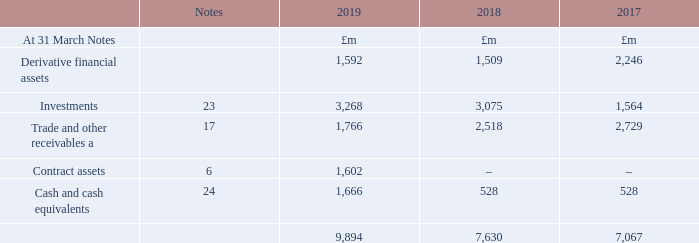Exposures The maximum credit risk exposure of the group’s financial assets at the balance sheet date is as follows:
The carrying amount excludes £445m (2017/18: £317m, 2016/17: £360m) of non-current trade and other receivables which relate to non-financial assets, and £1,456m (2017/18: £1,496m, 2016/17: £1,106m) of prepayments, deferred contract costs and other receivables.
What amount of non-current trade and other receivables was excluded from the carrying amount in 2019? £445m. What was the Derivative financial assets in 2019, 2018 and 2017?
Answer scale should be: million. 1,592, 1,509, 2,246. What is theCash and cash equivalents for 2017, 2018 and 2019 respectively?
Answer scale should be: million. 528, 528, 1,666. What is the change in the Derivative financial assets from 2018 to 2019?
Answer scale should be: million. 1,592 - 1,509
Answer: 83. What is the average investments for 2017 to 2019?
Answer scale should be: million. (3,268 + 3,075 + 1,564) / 3
Answer: 2635.67. In which year(s) was trade and other receivables less than 2,000 million? Locate and analyze trade and other receivables in row 5
answer: 2019. 